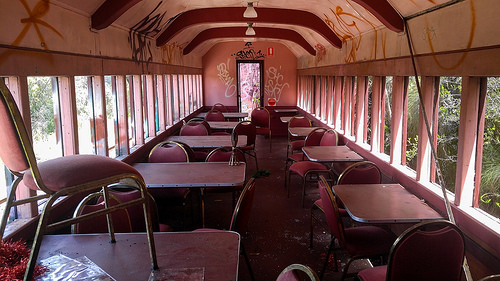<image>
Is there a graffiti in the railcar? Yes. The graffiti is contained within or inside the railcar, showing a containment relationship. 